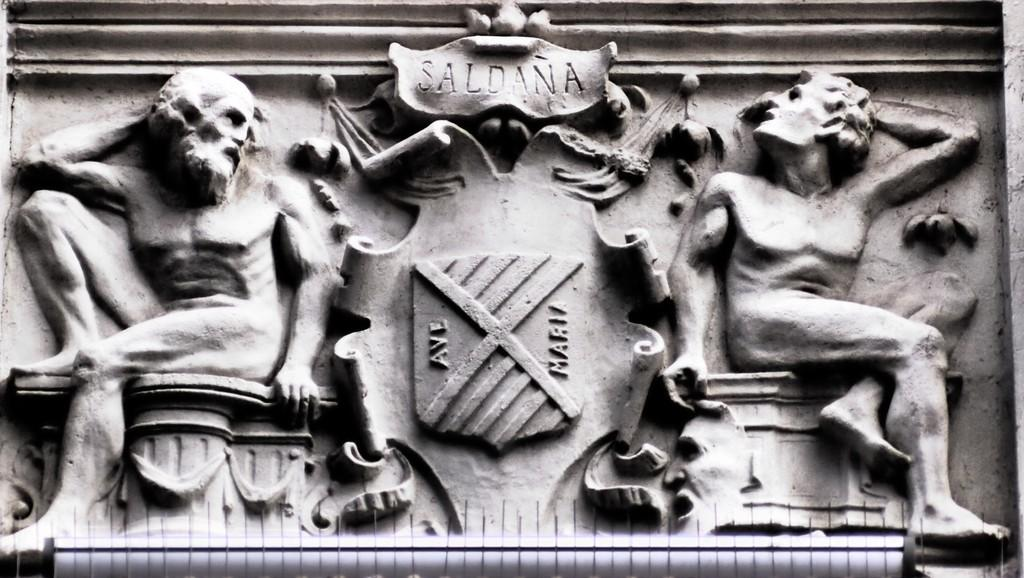<image>
Render a clear and concise summary of the photo. A sculpture containing two figures that commemorates the Saldana family. 